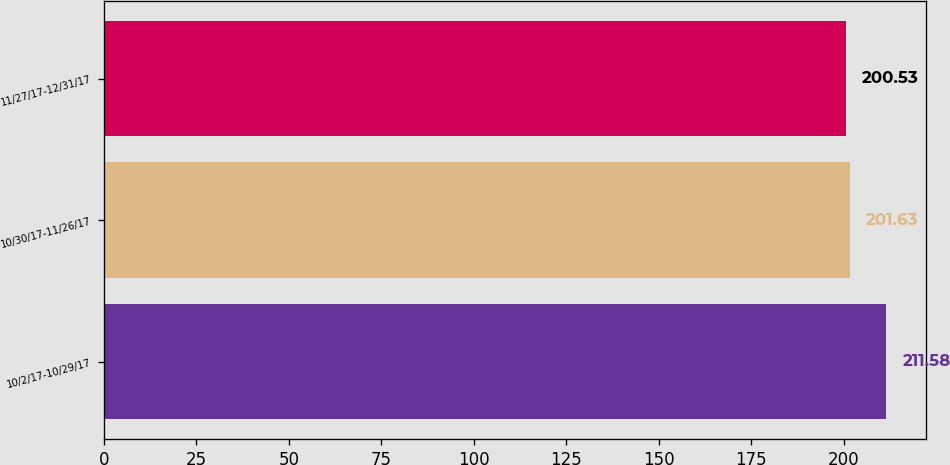<chart> <loc_0><loc_0><loc_500><loc_500><bar_chart><fcel>10/2/17-10/29/17<fcel>10/30/17-11/26/17<fcel>11/27/17-12/31/17<nl><fcel>211.58<fcel>201.63<fcel>200.53<nl></chart> 